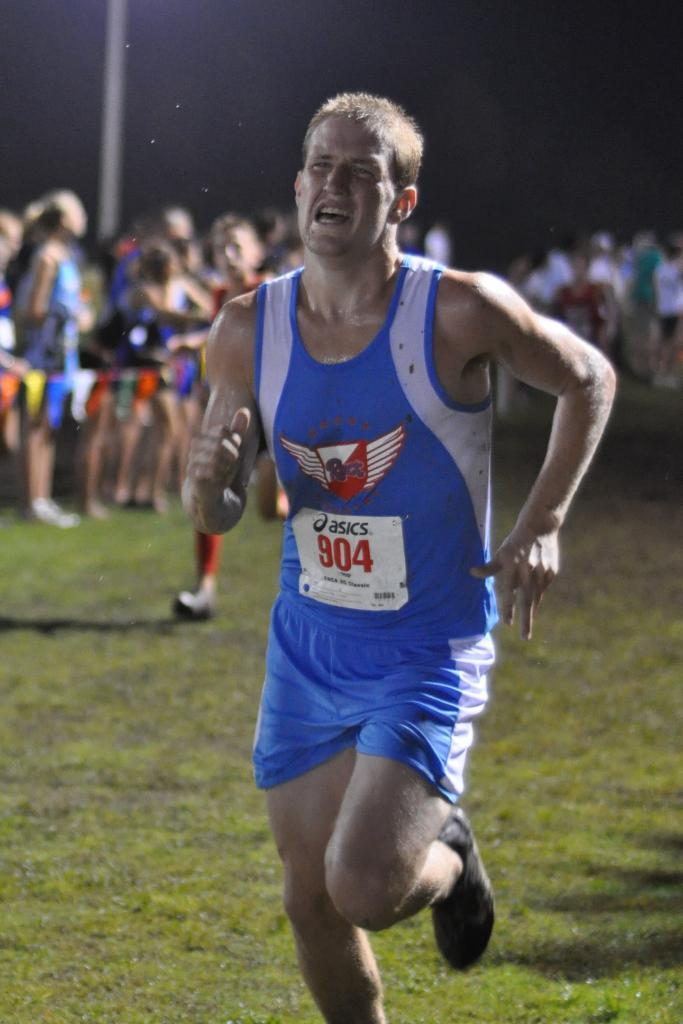<image>
Relay a brief, clear account of the picture shown. A guy is in a blue tank top with the number 904 on it. 